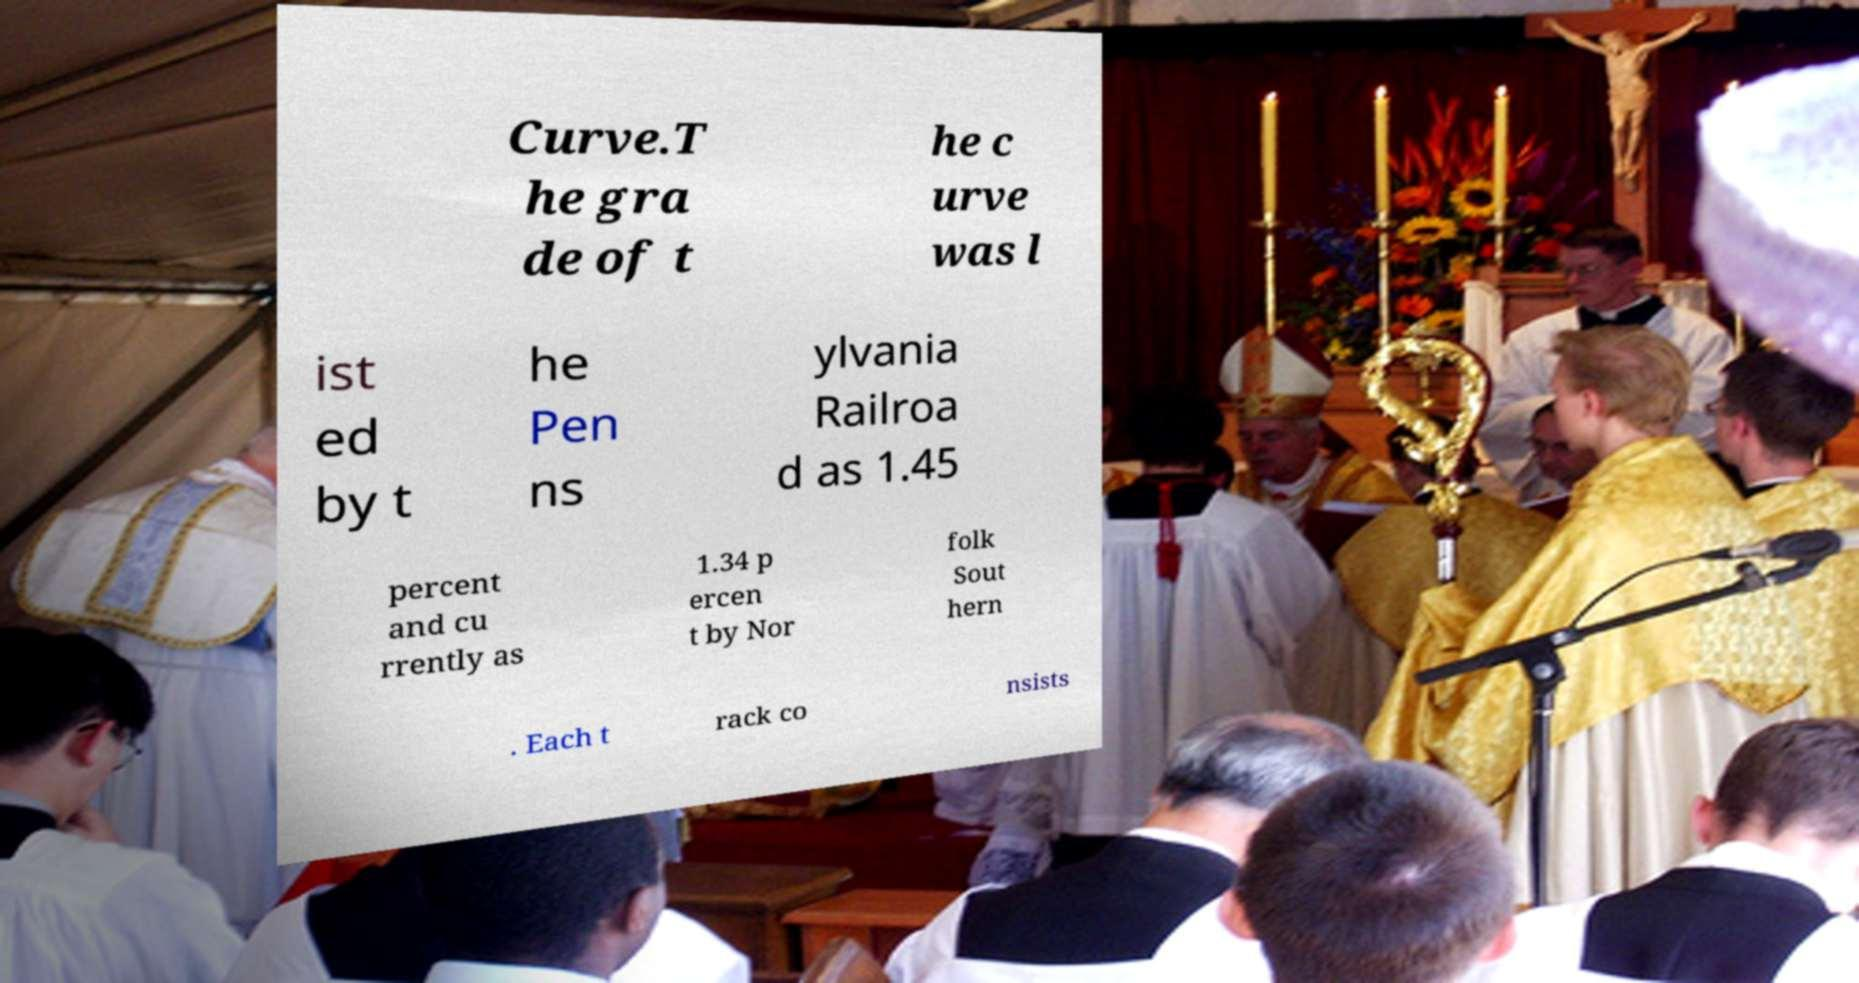Please identify and transcribe the text found in this image. Curve.T he gra de of t he c urve was l ist ed by t he Pen ns ylvania Railroa d as 1.45 percent and cu rrently as 1.34 p ercen t by Nor folk Sout hern . Each t rack co nsists 